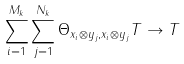Convert formula to latex. <formula><loc_0><loc_0><loc_500><loc_500>\sum _ { i = 1 } ^ { M _ { k } } \sum _ { j = 1 } ^ { N _ { k } } \Theta _ { x _ { i } \otimes y _ { j } , x _ { i } \otimes y _ { j } } T \to T</formula> 